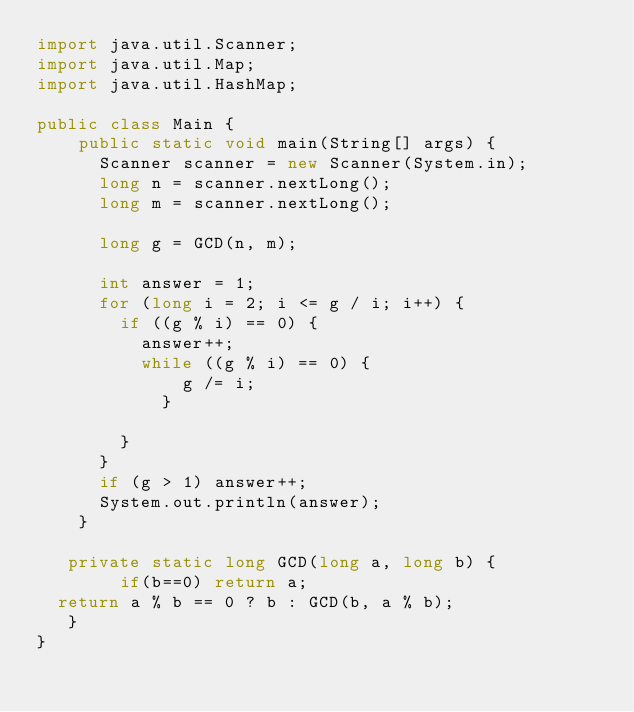Convert code to text. <code><loc_0><loc_0><loc_500><loc_500><_Java_>import java.util.Scanner;
import java.util.Map;
import java.util.HashMap;
 
public class Main {
    public static void main(String[] args) {
      Scanner scanner = new Scanner(System.in);
      long n = scanner.nextLong();
      long m = scanner.nextLong();
      
      long g = GCD(n, m);

      int answer = 1;
      for (long i = 2; i <= g / i; i++) {
      	if ((g % i) == 0) {
        	answer++;
        	while ((g % i) == 0) {
            	g /= i;
            }
          
        }
      }
      if (g > 1) answer++;
      System.out.println(answer);
    }
  
   private static long GCD(long a, long b) {
        if(b==0) return a; 
	return a % b == 0 ? b : GCD(b, a % b);
   }
}</code> 